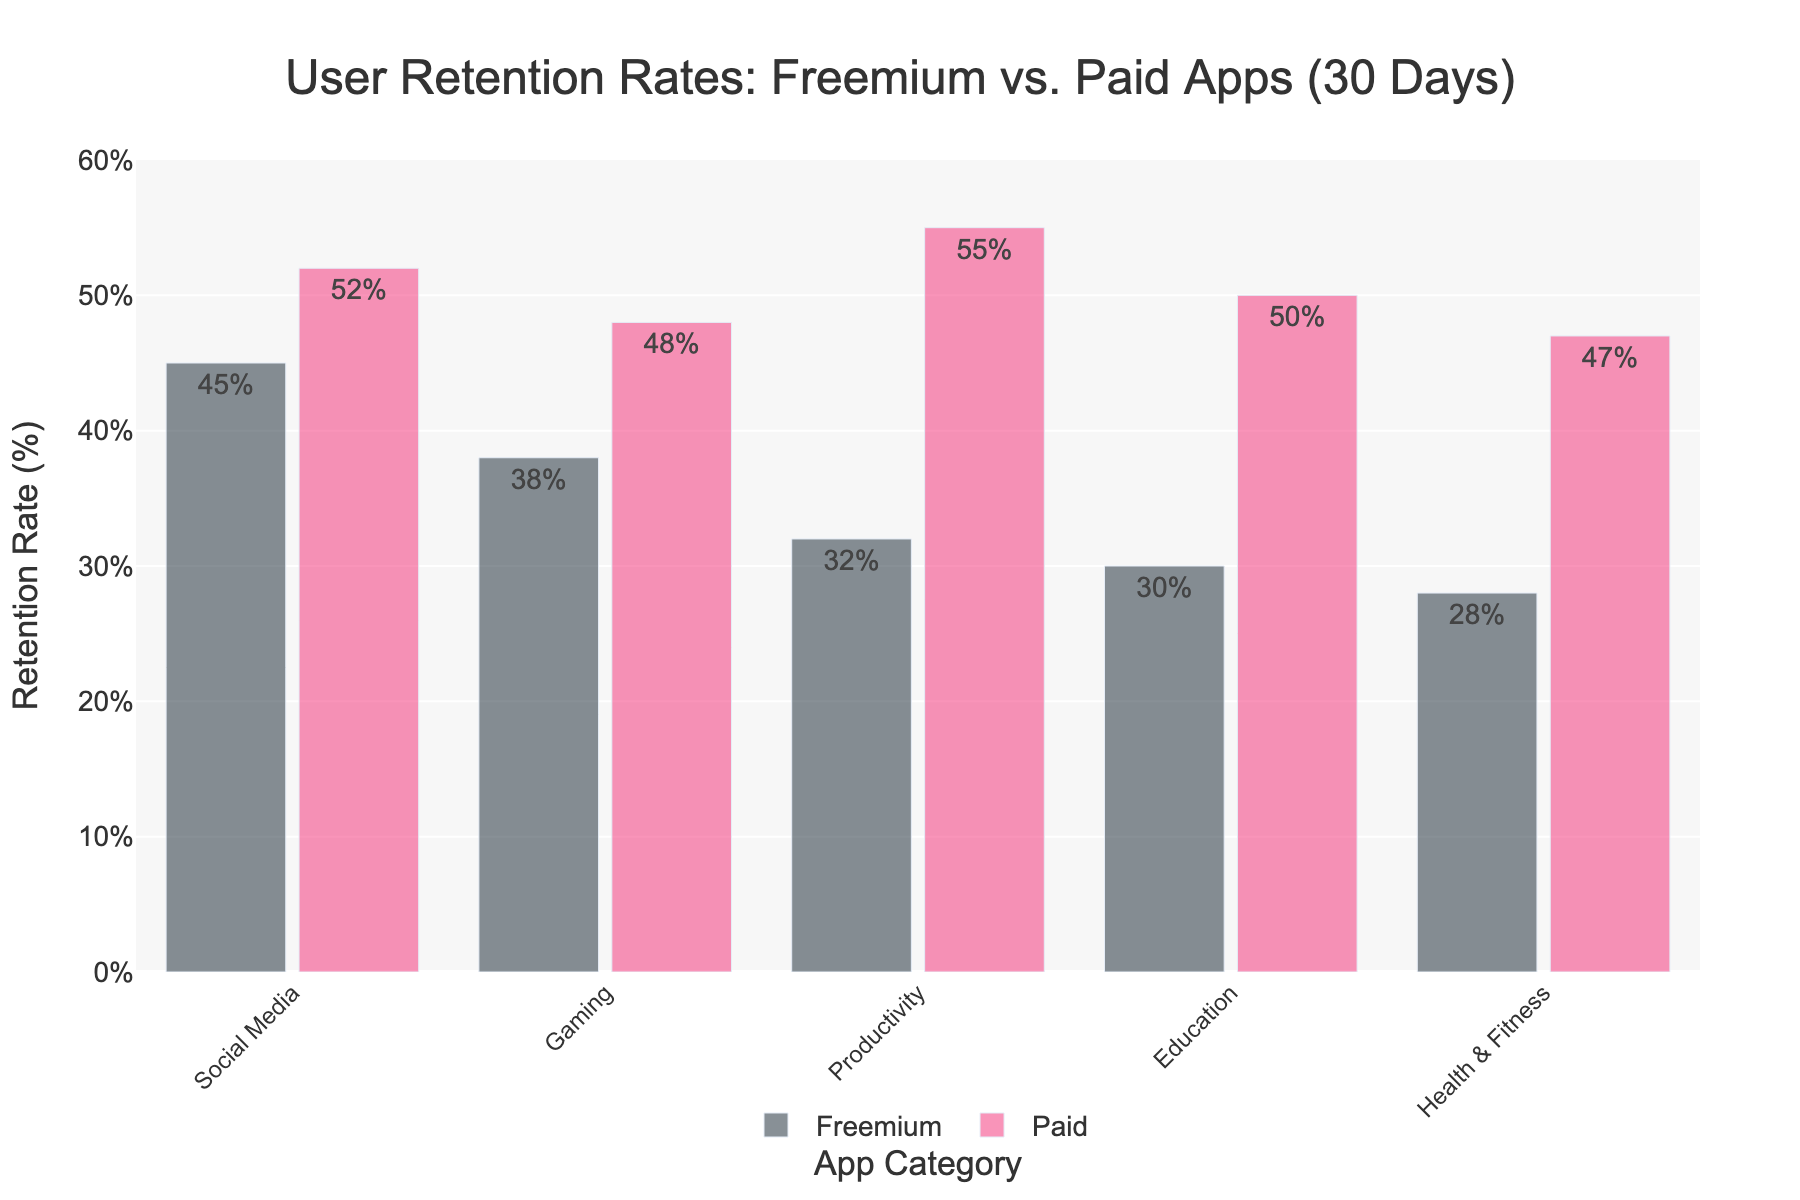Which app category has the highest retention rate for freemium apps? The bar chart shows different retention rates for various freemium app categories. The tallest bar among the freemium app categories represents the Social Media category at 45%.
Answer: Freemium Social Media How does the retention rate for paid gaming apps compare to freemium gaming apps? The bar for paid gaming apps is 48%, which is higher than the freemium gaming apps bar at 38%. Therefore, the retention rate for paid gaming apps is greater.
Answer: Paid gaming apps have higher retention rates What is the difference in retention rates between paid and freemium productivity apps? To find the difference, locate the bars for productivity apps in both freemium and paid sections. Freemium productivity apps have a retention rate of 32%, while paid productivity apps have a retention rate of 55%. Subtract the freemium rate from the paid rate: 55% - 32% = 23%.
Answer: 23% Which app category has the lowest retention rate among freemium apps, and what is this rate? By examining the heights of the bars in the freemium app categories, the Health & Fitness category has the shortest bar, indicating the lowest retention rate at 28%.
Answer: Freemium Health & Fitness, 28% Are retention rates generally higher for paid apps compared to freemium apps? Comparing the bars within each category, paid apps consistently have taller bars than their freemium counterparts, indicating higher retention rates across all categories.
Answer: Yes What is the average retention rate for paid apps across all categories? The retention rates for paid apps are 52%, 48%, 55%, 50%, and 47%. Add these rates together and divide by the number of categories (5). (52 + 48 + 55 + 50 + 47) / 5 = 252 / 5 = 50.4%.
Answer: 50.4% By how much does the retention rate of paid education apps exceed that of freemium education apps? Find the retention rates for education apps in both the paid and freemium sections. For paid education apps, the retention rate is 50%, and for freemium education apps, it is 30%. Subtract the freemium rate from the paid rate: 50% - 30% = 20%.
Answer: 20% Which visual cue helps to differentiate freemium apps from paid apps in the chart? The freemium app bars are depicted in a darker color, while the paid app bars are shown in a pinkish color. This color difference visually distinguishes the two types of apps.
Answer: Color What is the total retention rate for freemium and paid social media apps combined? Add the retention rates for freemium social media (45%) and paid social media (52%): 45% + 52% = 97%.
Answer: 97% Which paid app category has the second highest retention rate, and what is this rate? Among the paid app categories, Productivity has the highest retention rate at 55%. The next highest is Social Media with 52%, thus making it the second highest.
Answer: Paid Social Media, 52% 